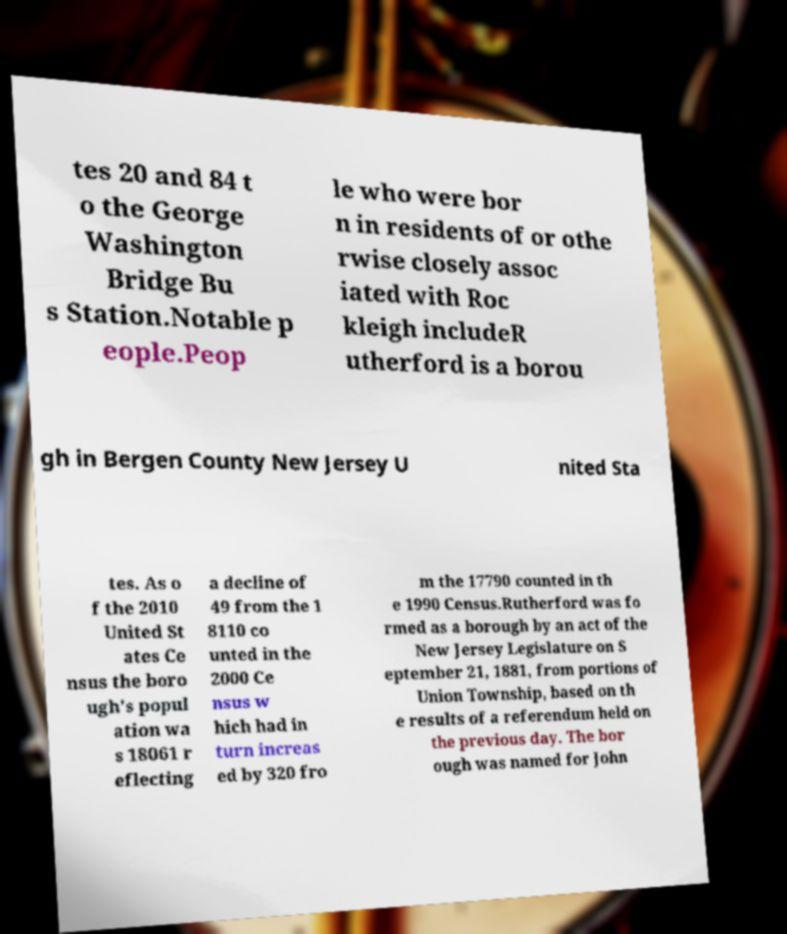Please identify and transcribe the text found in this image. tes 20 and 84 t o the George Washington Bridge Bu s Station.Notable p eople.Peop le who were bor n in residents of or othe rwise closely assoc iated with Roc kleigh includeR utherford is a borou gh in Bergen County New Jersey U nited Sta tes. As o f the 2010 United St ates Ce nsus the boro ugh's popul ation wa s 18061 r eflecting a decline of 49 from the 1 8110 co unted in the 2000 Ce nsus w hich had in turn increas ed by 320 fro m the 17790 counted in th e 1990 Census.Rutherford was fo rmed as a borough by an act of the New Jersey Legislature on S eptember 21, 1881, from portions of Union Township, based on th e results of a referendum held on the previous day. The bor ough was named for John 